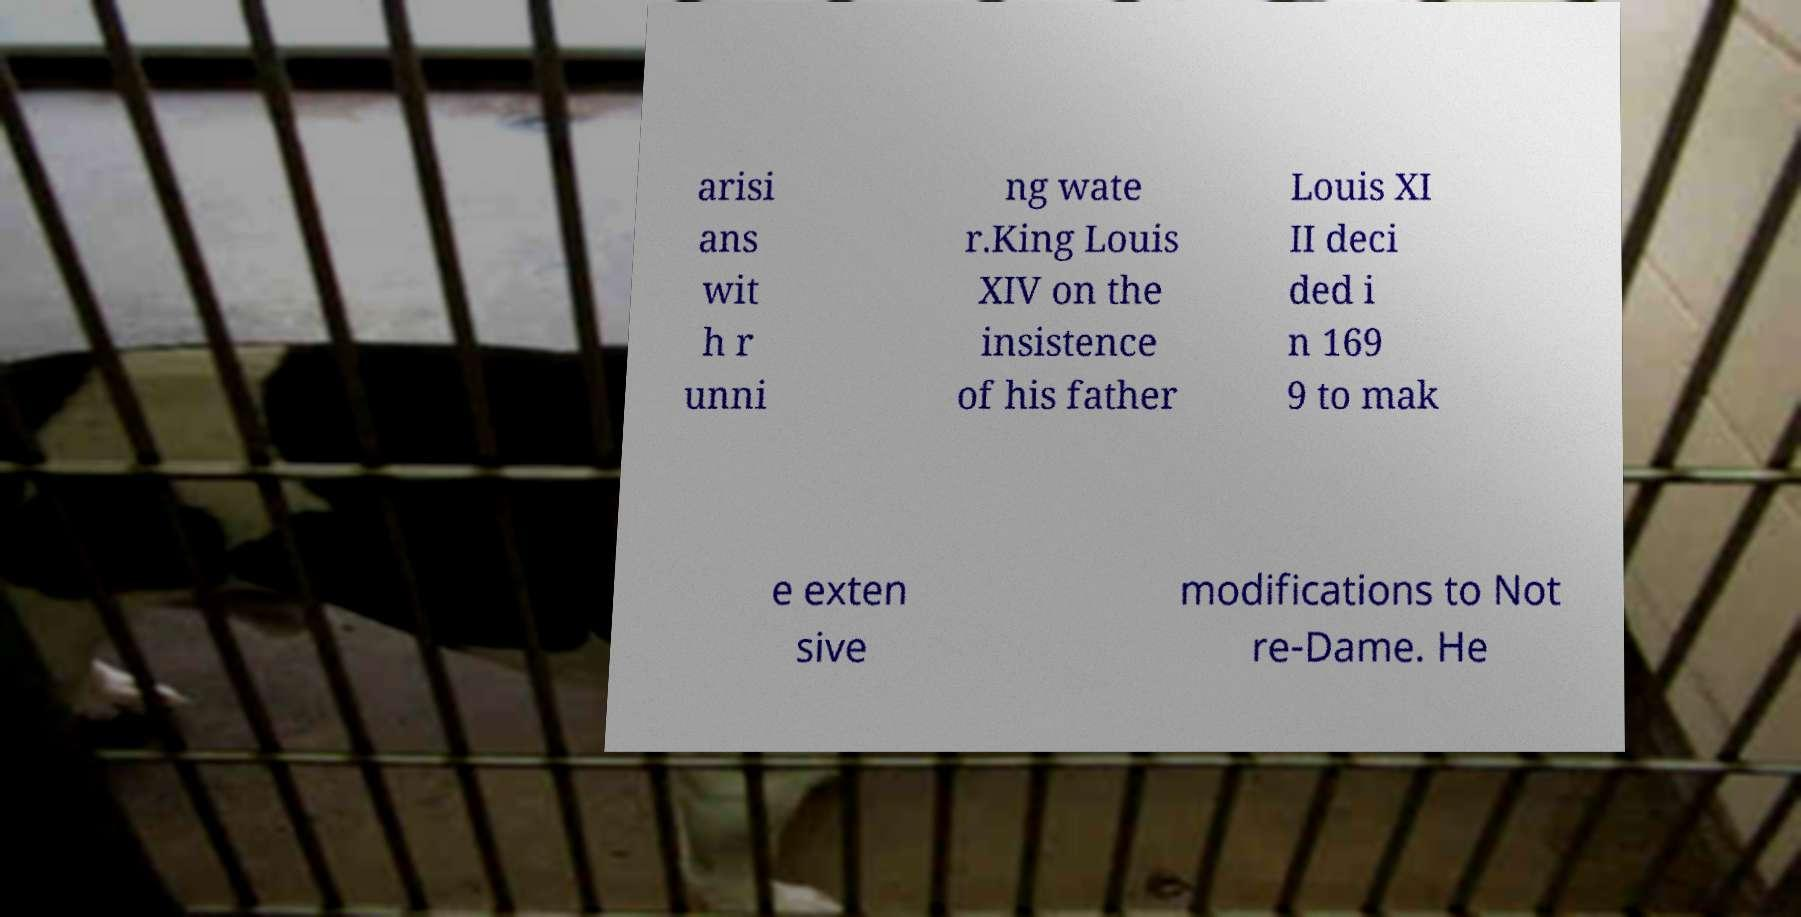What messages or text are displayed in this image? I need them in a readable, typed format. arisi ans wit h r unni ng wate r.King Louis XIV on the insistence of his father Louis XI II deci ded i n 169 9 to mak e exten sive modifications to Not re-Dame. He 